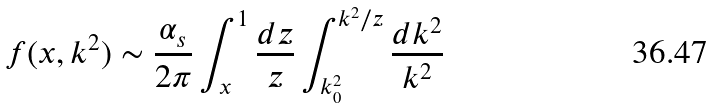Convert formula to latex. <formula><loc_0><loc_0><loc_500><loc_500>f ( x , k ^ { 2 } ) \sim \frac { \alpha _ { s } } { 2 \pi } \int _ { x } ^ { 1 } \frac { d z } { z } \int _ { k _ { 0 } ^ { 2 } } ^ { k ^ { 2 } / z } \frac { d k ^ { 2 } } { k ^ { 2 } }</formula> 